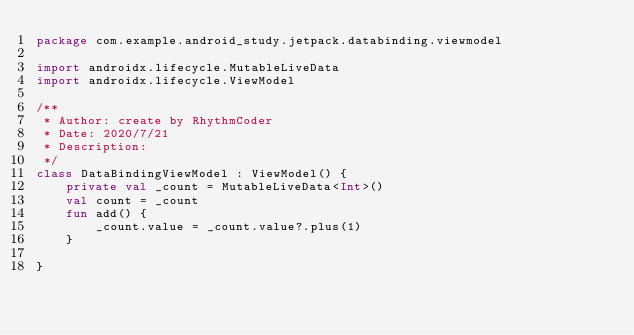Convert code to text. <code><loc_0><loc_0><loc_500><loc_500><_Kotlin_>package com.example.android_study.jetpack.databinding.viewmodel

import androidx.lifecycle.MutableLiveData
import androidx.lifecycle.ViewModel

/**
 * Author: create by RhythmCoder
 * Date: 2020/7/21
 * Description:
 */
class DataBindingViewModel : ViewModel() {
    private val _count = MutableLiveData<Int>()
    val count = _count
    fun add() {
        _count.value = _count.value?.plus(1)
    }

}</code> 